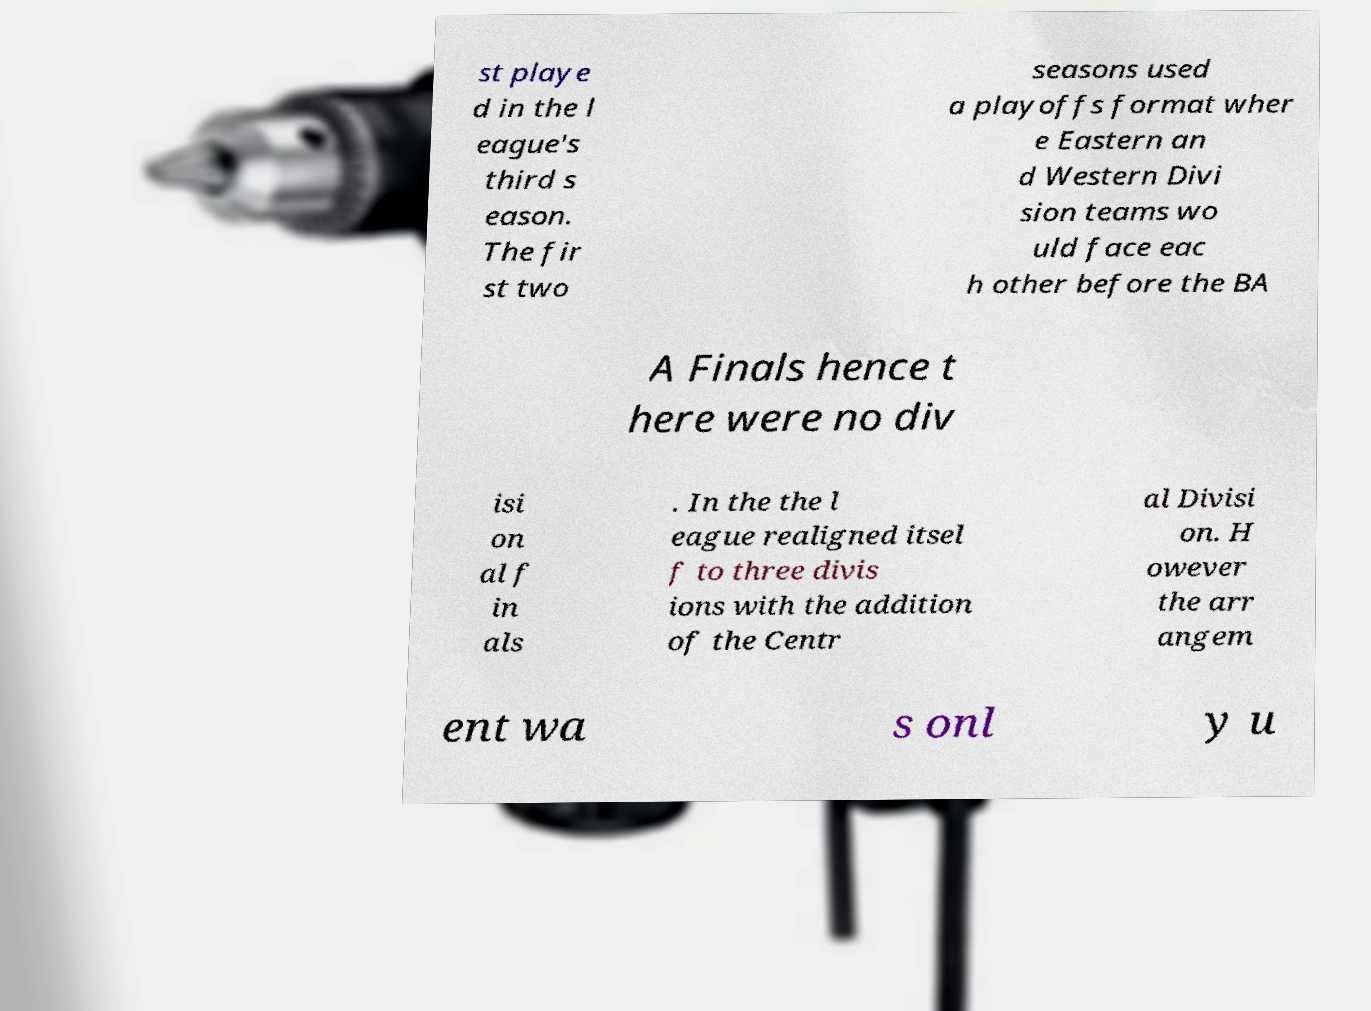Please read and relay the text visible in this image. What does it say? st playe d in the l eague's third s eason. The fir st two seasons used a playoffs format wher e Eastern an d Western Divi sion teams wo uld face eac h other before the BA A Finals hence t here were no div isi on al f in als . In the the l eague realigned itsel f to three divis ions with the addition of the Centr al Divisi on. H owever the arr angem ent wa s onl y u 